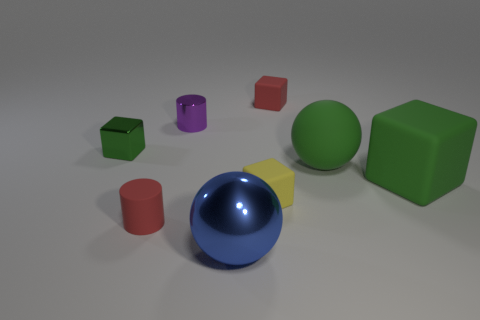Subtract 1 cubes. How many cubes are left? 3 Add 1 big blue metal cylinders. How many objects exist? 9 Subtract all spheres. How many objects are left? 6 Add 6 large spheres. How many large spheres are left? 8 Add 7 big gray rubber cylinders. How many big gray rubber cylinders exist? 7 Subtract 0 blue blocks. How many objects are left? 8 Subtract all blue shiny spheres. Subtract all small purple cylinders. How many objects are left? 6 